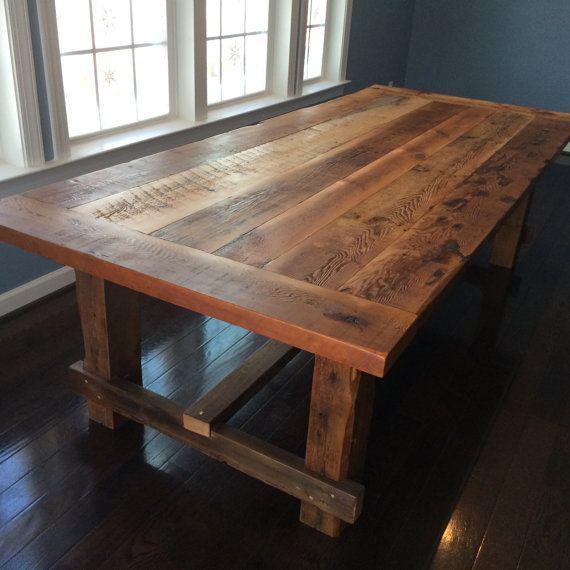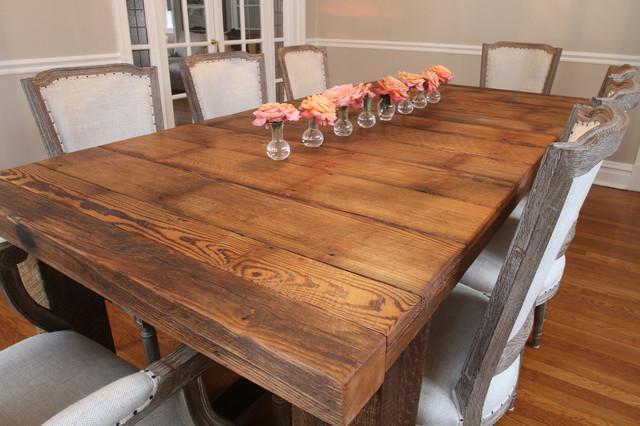The first image is the image on the left, the second image is the image on the right. Given the left and right images, does the statement "A rectangular wooden dining table is shown with at least four chairs in one image." hold true? Answer yes or no. Yes. 